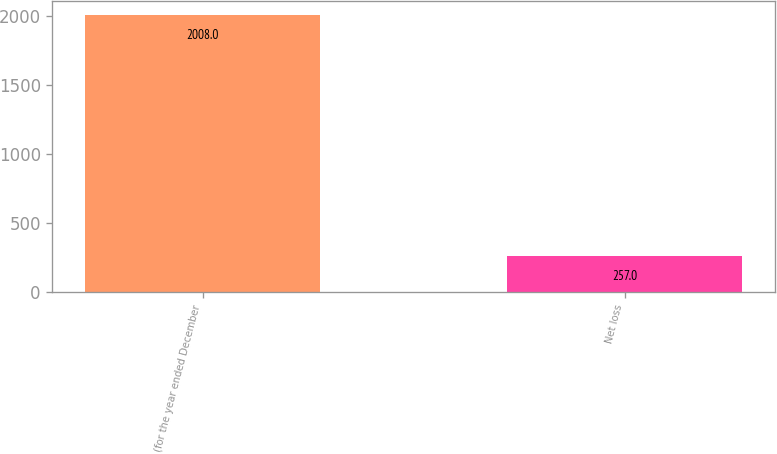Convert chart. <chart><loc_0><loc_0><loc_500><loc_500><bar_chart><fcel>(for the year ended December<fcel>Net loss<nl><fcel>2008<fcel>257<nl></chart> 